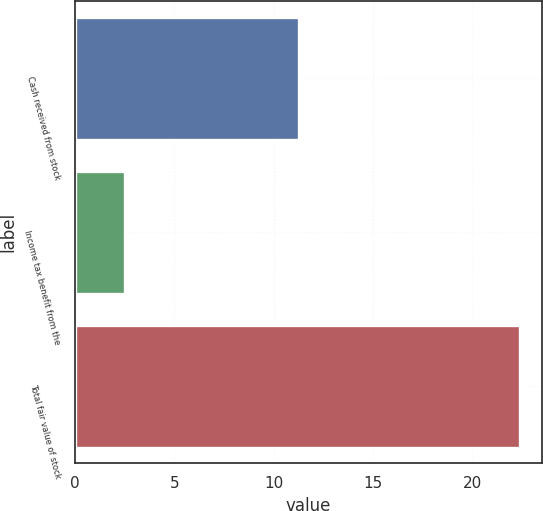Convert chart. <chart><loc_0><loc_0><loc_500><loc_500><bar_chart><fcel>Cash received from stock<fcel>Income tax benefit from the<fcel>Total fair value of stock<nl><fcel>11.3<fcel>2.5<fcel>22.4<nl></chart> 